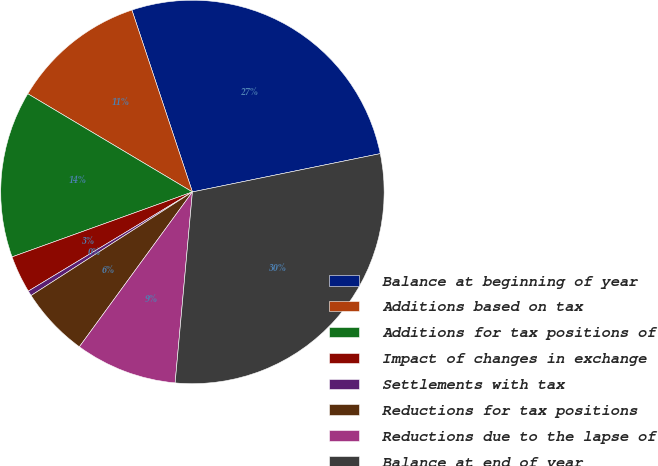Convert chart to OTSL. <chart><loc_0><loc_0><loc_500><loc_500><pie_chart><fcel>Balance at beginning of year<fcel>Additions based on tax<fcel>Additions for tax positions of<fcel>Impact of changes in exchange<fcel>Settlements with tax<fcel>Reductions for tax positions<fcel>Reductions due to the lapse of<fcel>Balance at end of year<nl><fcel>26.91%<fcel>11.33%<fcel>14.06%<fcel>3.15%<fcel>0.43%<fcel>5.88%<fcel>8.6%<fcel>29.64%<nl></chart> 